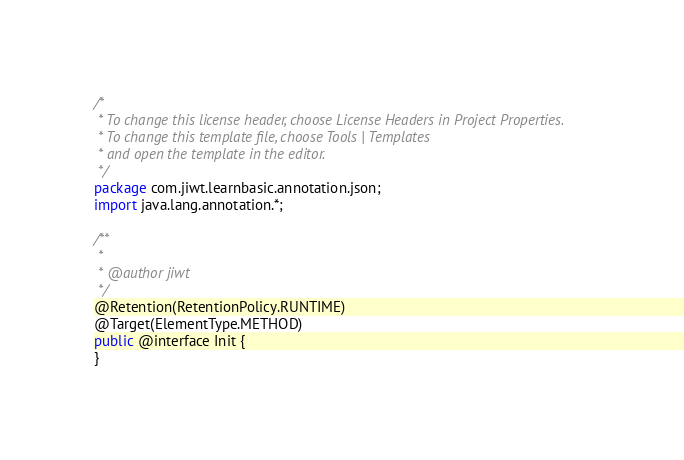<code> <loc_0><loc_0><loc_500><loc_500><_Java_>/*
 * To change this license header, choose License Headers in Project Properties.
 * To change this template file, choose Tools | Templates
 * and open the template in the editor.
 */
package com.jiwt.learnbasic.annotation.json;
import java.lang.annotation.*;

/**
 *
 * @author jiwt
 */
@Retention(RetentionPolicy.RUNTIME)
@Target(ElementType.METHOD)
public @interface Init {
}</code> 